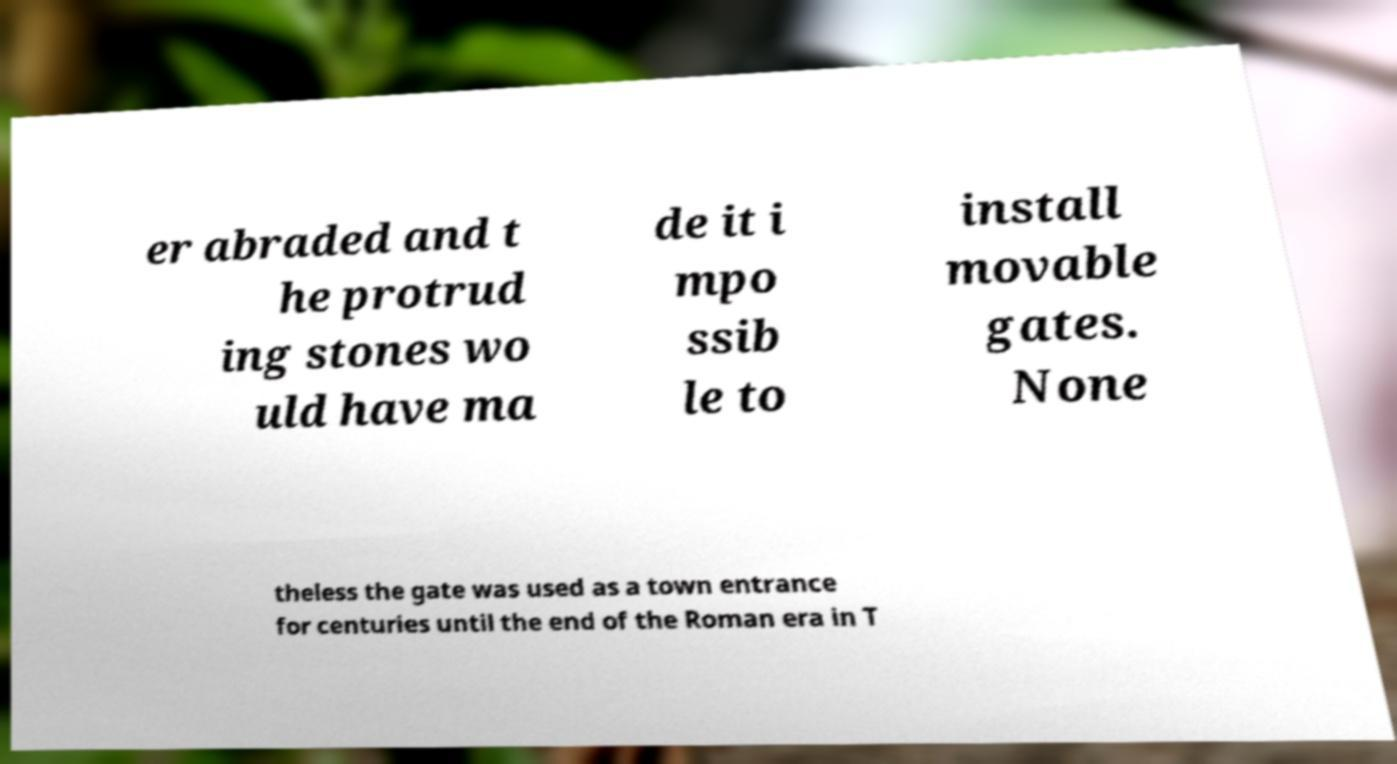For documentation purposes, I need the text within this image transcribed. Could you provide that? er abraded and t he protrud ing stones wo uld have ma de it i mpo ssib le to install movable gates. None theless the gate was used as a town entrance for centuries until the end of the Roman era in T 